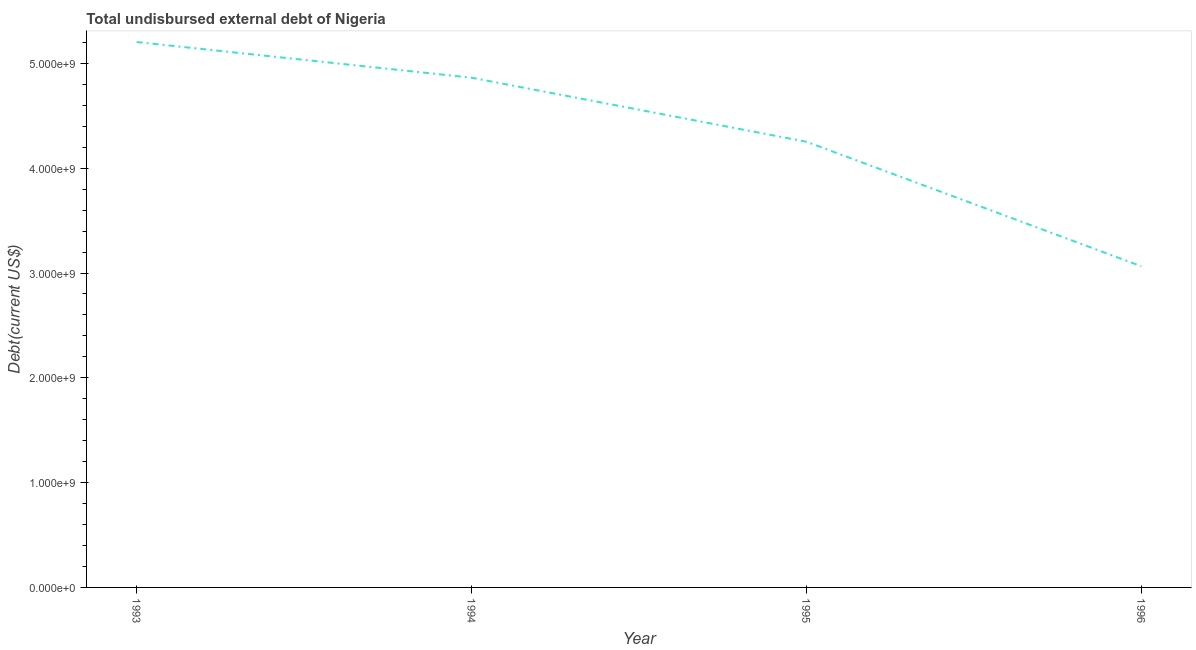What is the total debt in 1994?
Offer a very short reply. 4.86e+09. Across all years, what is the maximum total debt?
Give a very brief answer. 5.20e+09. Across all years, what is the minimum total debt?
Your response must be concise. 3.06e+09. In which year was the total debt maximum?
Offer a terse response. 1993. What is the sum of the total debt?
Offer a terse response. 1.74e+1. What is the difference between the total debt in 1994 and 1996?
Make the answer very short. 1.80e+09. What is the average total debt per year?
Make the answer very short. 4.35e+09. What is the median total debt?
Provide a succinct answer. 4.56e+09. Do a majority of the years between 1996 and 1994 (inclusive) have total debt greater than 5000000000 US$?
Make the answer very short. No. What is the ratio of the total debt in 1993 to that in 1996?
Provide a succinct answer. 1.7. Is the total debt in 1993 less than that in 1994?
Make the answer very short. No. What is the difference between the highest and the second highest total debt?
Ensure brevity in your answer.  3.40e+08. Is the sum of the total debt in 1994 and 1995 greater than the maximum total debt across all years?
Your response must be concise. Yes. What is the difference between the highest and the lowest total debt?
Make the answer very short. 2.14e+09. How many lines are there?
Give a very brief answer. 1. What is the difference between two consecutive major ticks on the Y-axis?
Your answer should be very brief. 1.00e+09. Does the graph contain any zero values?
Your response must be concise. No. Does the graph contain grids?
Make the answer very short. No. What is the title of the graph?
Make the answer very short. Total undisbursed external debt of Nigeria. What is the label or title of the Y-axis?
Offer a terse response. Debt(current US$). What is the Debt(current US$) in 1993?
Your response must be concise. 5.20e+09. What is the Debt(current US$) of 1994?
Your answer should be compact. 4.86e+09. What is the Debt(current US$) of 1995?
Offer a very short reply. 4.25e+09. What is the Debt(current US$) of 1996?
Give a very brief answer. 3.06e+09. What is the difference between the Debt(current US$) in 1993 and 1994?
Give a very brief answer. 3.40e+08. What is the difference between the Debt(current US$) in 1993 and 1995?
Your answer should be compact. 9.51e+08. What is the difference between the Debt(current US$) in 1993 and 1996?
Your response must be concise. 2.14e+09. What is the difference between the Debt(current US$) in 1994 and 1995?
Make the answer very short. 6.11e+08. What is the difference between the Debt(current US$) in 1994 and 1996?
Offer a very short reply. 1.80e+09. What is the difference between the Debt(current US$) in 1995 and 1996?
Ensure brevity in your answer.  1.19e+09. What is the ratio of the Debt(current US$) in 1993 to that in 1994?
Your answer should be compact. 1.07. What is the ratio of the Debt(current US$) in 1993 to that in 1995?
Give a very brief answer. 1.22. What is the ratio of the Debt(current US$) in 1993 to that in 1996?
Provide a succinct answer. 1.7. What is the ratio of the Debt(current US$) in 1994 to that in 1995?
Your answer should be very brief. 1.14. What is the ratio of the Debt(current US$) in 1994 to that in 1996?
Your answer should be compact. 1.59. What is the ratio of the Debt(current US$) in 1995 to that in 1996?
Your response must be concise. 1.39. 